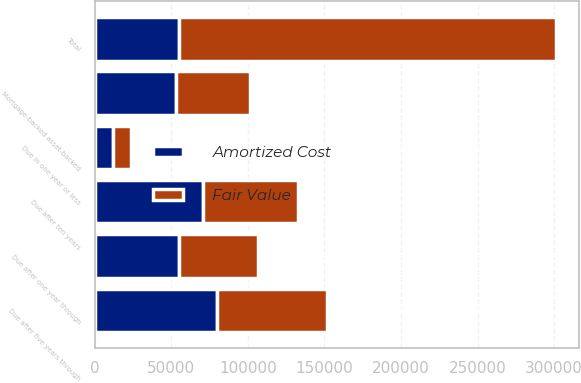Convert chart to OTSL. <chart><loc_0><loc_0><loc_500><loc_500><stacked_bar_chart><ecel><fcel>Due in one year or less<fcel>Due after one year through<fcel>Due after five years through<fcel>Due after ten years<fcel>Mortgage-backed asset-backed<fcel>Total<nl><fcel>Fair Value<fcel>11801<fcel>51646<fcel>72091<fcel>61842<fcel>48769<fcel>246149<nl><fcel>Amortized Cost<fcel>12001<fcel>54918<fcel>79531<fcel>70650<fcel>52859<fcel>54918<nl></chart> 